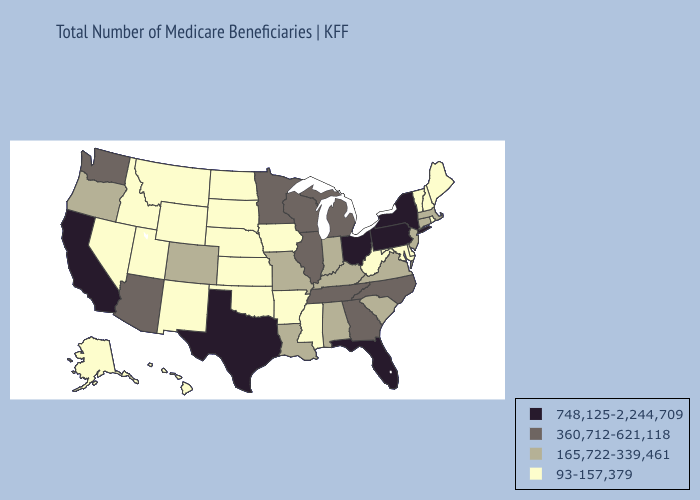Does New Jersey have the lowest value in the Northeast?
Write a very short answer. No. Does Pennsylvania have the lowest value in the USA?
Give a very brief answer. No. Name the states that have a value in the range 748,125-2,244,709?
Short answer required. California, Florida, New York, Ohio, Pennsylvania, Texas. Which states hav the highest value in the Northeast?
Keep it brief. New York, Pennsylvania. What is the value of Idaho?
Quick response, please. 93-157,379. Which states hav the highest value in the Northeast?
Give a very brief answer. New York, Pennsylvania. Does the first symbol in the legend represent the smallest category?
Short answer required. No. What is the value of Arizona?
Keep it brief. 360,712-621,118. What is the value of Idaho?
Write a very short answer. 93-157,379. Among the states that border New Hampshire , does Vermont have the lowest value?
Answer briefly. Yes. Which states have the lowest value in the Northeast?
Short answer required. Maine, New Hampshire, Rhode Island, Vermont. Does Florida have the lowest value in the South?
Be succinct. No. What is the lowest value in states that border Tennessee?
Give a very brief answer. 93-157,379. What is the highest value in the MidWest ?
Give a very brief answer. 748,125-2,244,709. Among the states that border Kansas , which have the lowest value?
Concise answer only. Nebraska, Oklahoma. 